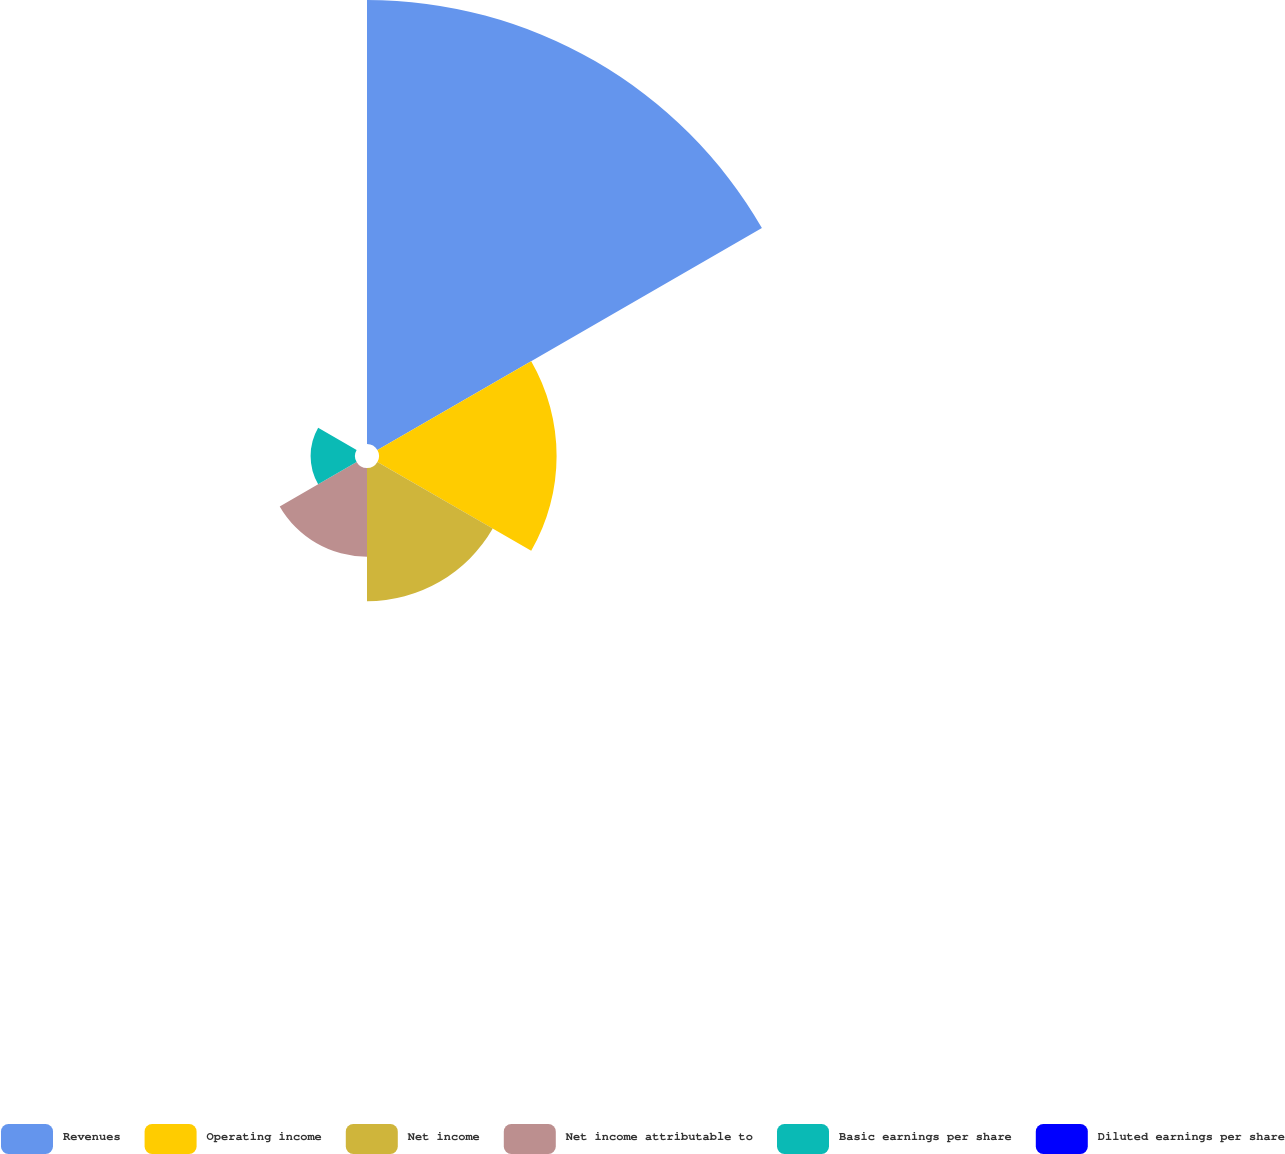Convert chart to OTSL. <chart><loc_0><loc_0><loc_500><loc_500><pie_chart><fcel>Revenues<fcel>Operating income<fcel>Net income<fcel>Net income attributable to<fcel>Basic earnings per share<fcel>Diluted earnings per share<nl><fcel>50.0%<fcel>20.0%<fcel>15.0%<fcel>10.0%<fcel>5.0%<fcel>0.0%<nl></chart> 